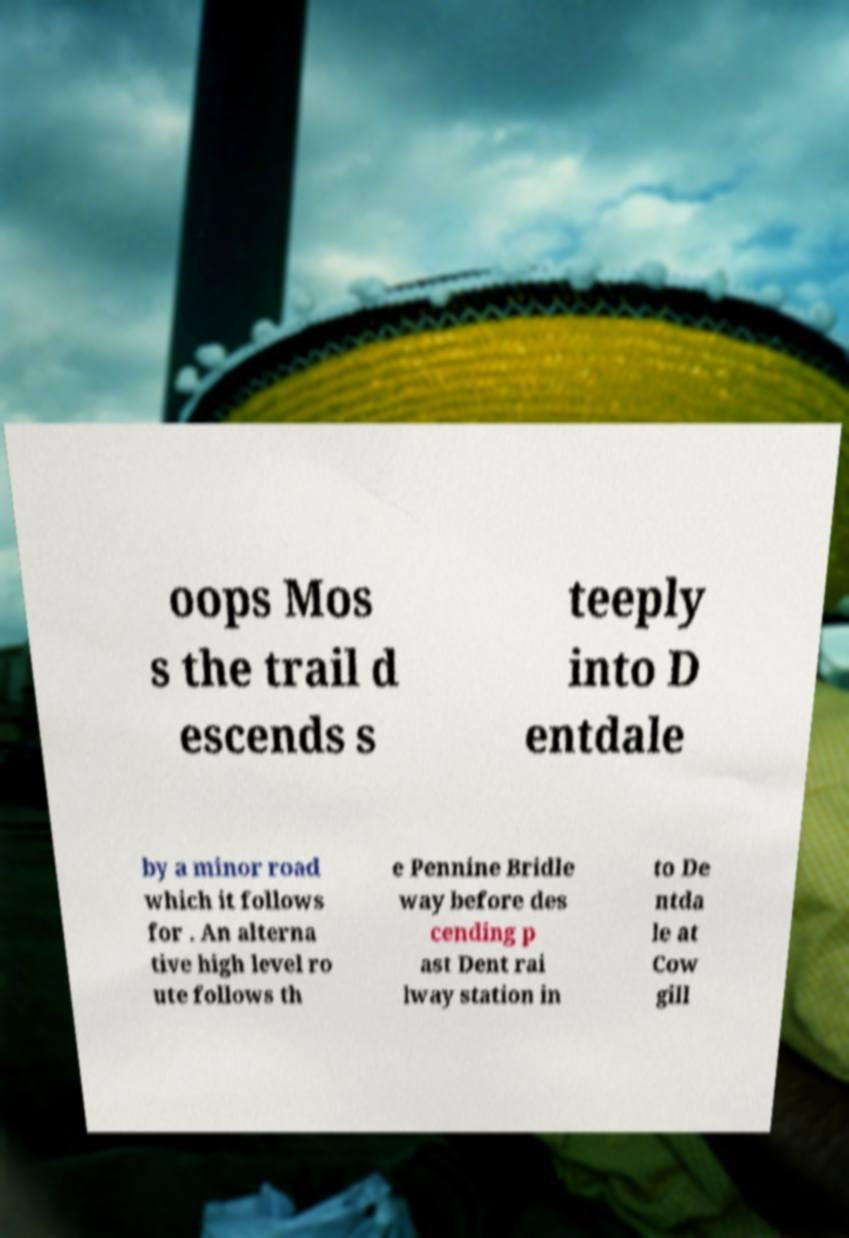Please read and relay the text visible in this image. What does it say? oops Mos s the trail d escends s teeply into D entdale by a minor road which it follows for . An alterna tive high level ro ute follows th e Pennine Bridle way before des cending p ast Dent rai lway station in to De ntda le at Cow gill 